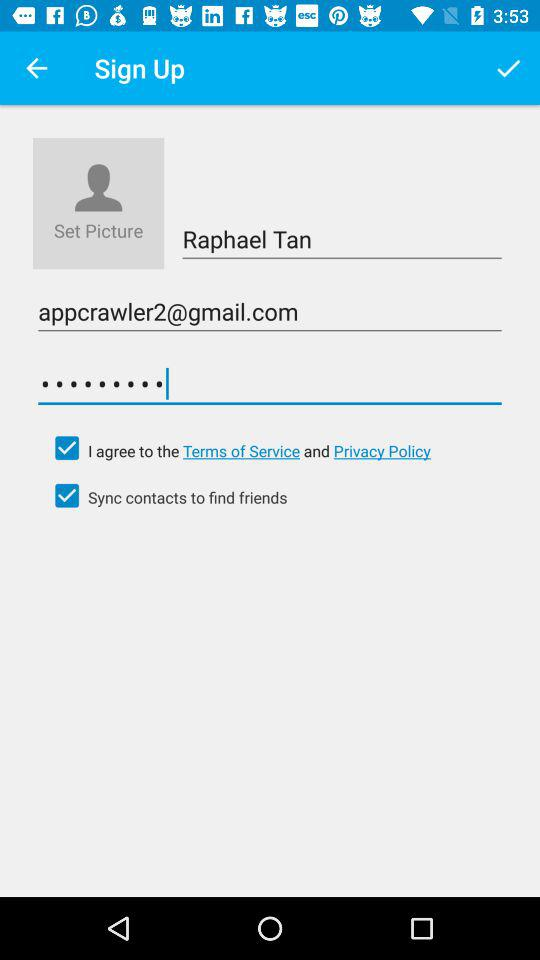How many checkboxes are on the screen?
Answer the question using a single word or phrase. 2 